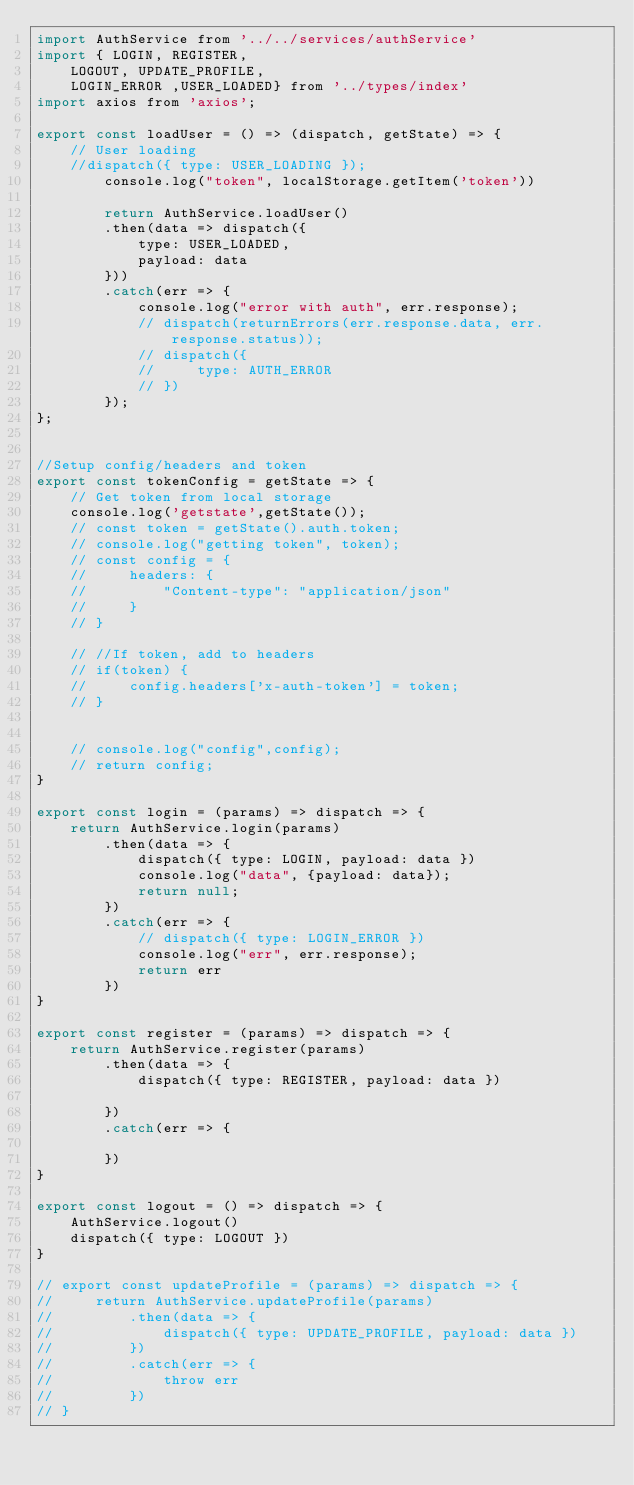<code> <loc_0><loc_0><loc_500><loc_500><_JavaScript_>import AuthService from '../../services/authService'
import { LOGIN, REGISTER, 
    LOGOUT, UPDATE_PROFILE,
    LOGIN_ERROR ,USER_LOADED} from '../types/index'
import axios from 'axios'; 

export const loadUser = () => (dispatch, getState) => {
    // User loading
    //dispatch({ type: USER_LOADING });
        console.log("token", localStorage.getItem('token'))

        return AuthService.loadUser()
        .then(data => dispatch({
            type: USER_LOADED,
            payload: data
        }))
        .catch(err => {
            console.log("error with auth", err.response);
            // dispatch(returnErrors(err.response.data, err.response.status));
            // dispatch({
            //     type: AUTH_ERROR
            // })
        });
};


//Setup config/headers and token
export const tokenConfig = getState => {
    // Get token from local storage
    console.log('getstate',getState());
    // const token = getState().auth.token;
    // console.log("getting token", token);
    // const config = {
    //     headers: {
    //         "Content-type": "application/json"
    //     }
    // }

    // //If token, add to headers
    // if(token) {
    //     config.headers['x-auth-token'] = token;
    // }


    // console.log("config",config);
    // return config;
}

export const login = (params) => dispatch => {
    return AuthService.login(params)
        .then(data => {
            dispatch({ type: LOGIN, payload: data })
            console.log("data", {payload: data}); 
            return null;
        })
        .catch(err => {
            // dispatch({ type: LOGIN_ERROR })
            console.log("err", err.response); 
            return err
        })
}

export const register = (params) => dispatch => {
    return AuthService.register(params)
        .then(data => {
            dispatch({ type: REGISTER, payload: data })
            
        })
        .catch(err => {

        })
}

export const logout = () => dispatch => {
    AuthService.logout()
    dispatch({ type: LOGOUT })
}

// export const updateProfile = (params) => dispatch => {
//     return AuthService.updateProfile(params)
//         .then(data => {
//             dispatch({ type: UPDATE_PROFILE, payload: data })
//         })
//         .catch(err => {
//             throw err
//         })
// }</code> 